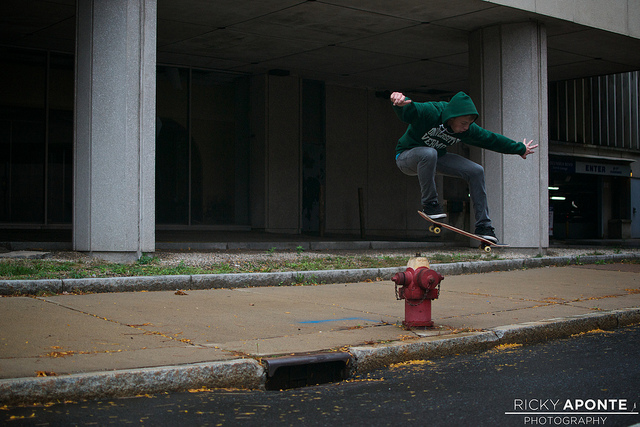Identify and read out the text in this image. RICKY APONTE PHOTOGRAPHY 